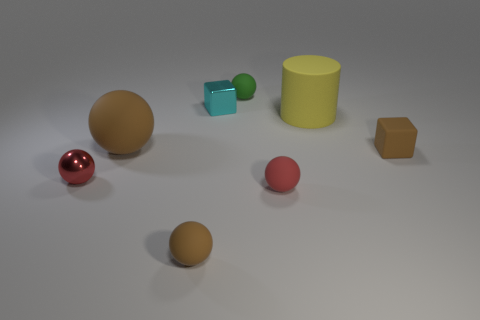Subtract all big balls. How many balls are left? 4 Add 2 small yellow shiny blocks. How many objects exist? 10 Subtract all cyan cubes. How many cubes are left? 1 Subtract 0 gray blocks. How many objects are left? 8 Subtract all cylinders. How many objects are left? 7 Subtract 1 cylinders. How many cylinders are left? 0 Subtract all brown blocks. Subtract all gray balls. How many blocks are left? 1 Subtract all green cubes. How many green balls are left? 1 Subtract all shiny objects. Subtract all brown rubber things. How many objects are left? 3 Add 4 tiny green rubber things. How many tiny green rubber things are left? 5 